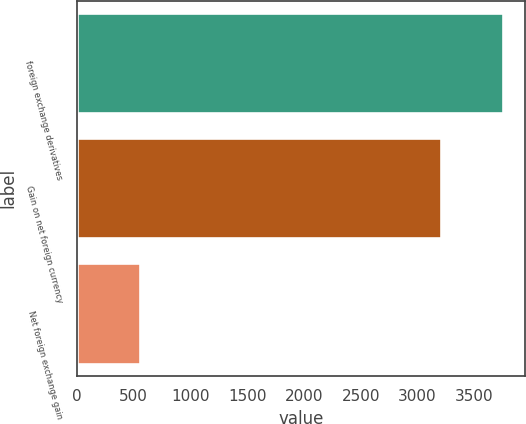Convert chart to OTSL. <chart><loc_0><loc_0><loc_500><loc_500><bar_chart><fcel>foreign exchange derivatives<fcel>Gain on net foreign currency<fcel>Net foreign exchange gain<nl><fcel>3756<fcel>3204<fcel>552<nl></chart> 